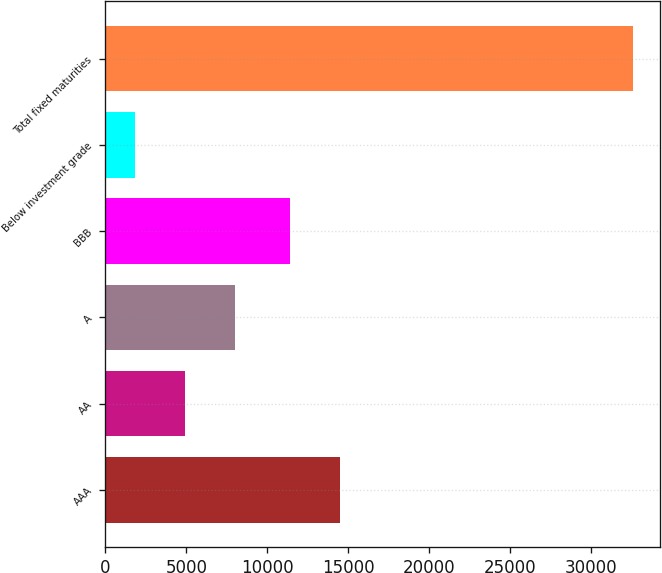<chart> <loc_0><loc_0><loc_500><loc_500><bar_chart><fcel>AAA<fcel>AA<fcel>A<fcel>BBB<fcel>Below investment grade<fcel>Total fixed maturities<nl><fcel>14486.6<fcel>4901.6<fcel>7980.2<fcel>11408<fcel>1823<fcel>32609<nl></chart> 